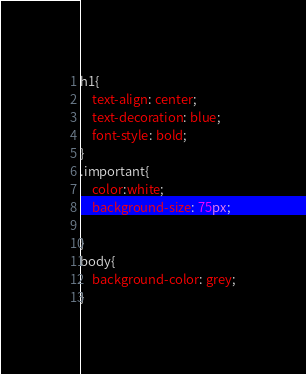Convert code to text. <code><loc_0><loc_0><loc_500><loc_500><_CSS_>h1{
    text-align: center;
    text-decoration: blue;
    font-style: bold;
}
.important{
    color:white;
    background-size: 75px;
    
}
body{
    background-color: grey;
}</code> 